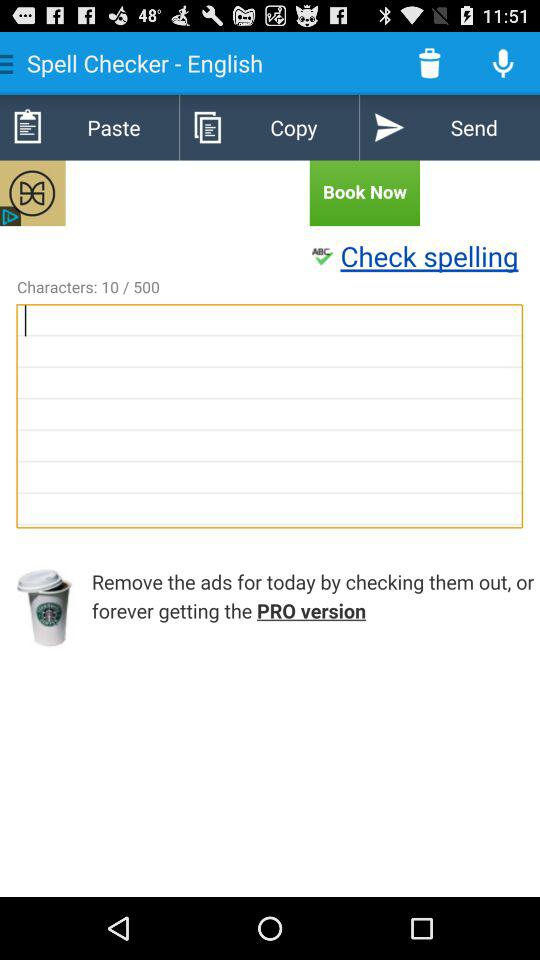How many characters are written? There are 10 characters written. 